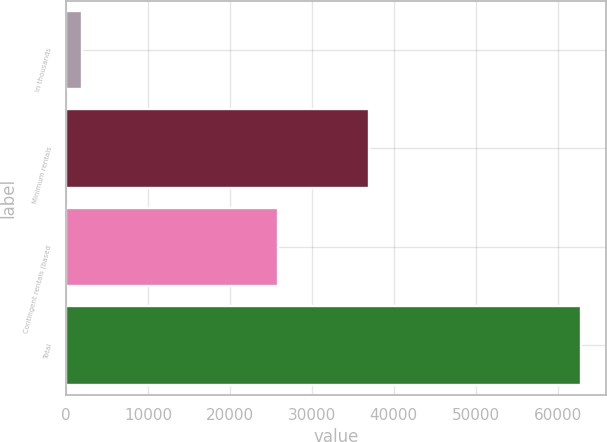<chart> <loc_0><loc_0><loc_500><loc_500><bar_chart><fcel>in thousands<fcel>Minimum rentals<fcel>Contingent rentals (based<fcel>Total<nl><fcel>2009<fcel>36976<fcel>25846<fcel>62822<nl></chart> 